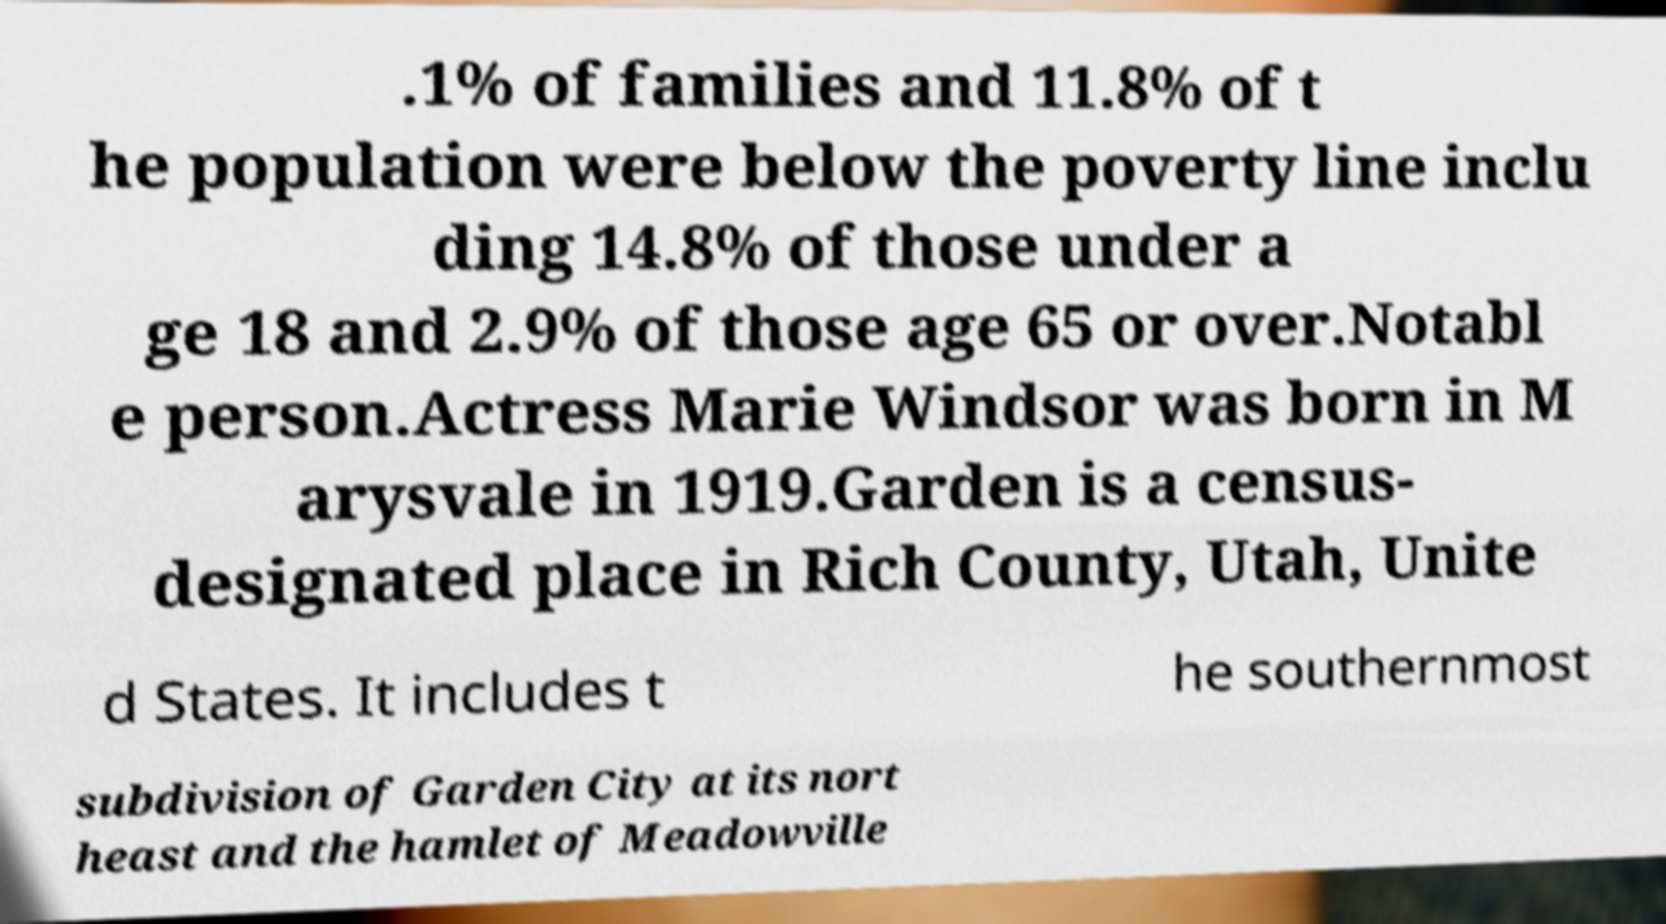I need the written content from this picture converted into text. Can you do that? .1% of families and 11.8% of t he population were below the poverty line inclu ding 14.8% of those under a ge 18 and 2.9% of those age 65 or over.Notabl e person.Actress Marie Windsor was born in M arysvale in 1919.Garden is a census- designated place in Rich County, Utah, Unite d States. It includes t he southernmost subdivision of Garden City at its nort heast and the hamlet of Meadowville 